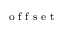<formula> <loc_0><loc_0><loc_500><loc_500>_ { o f f s e t }</formula> 